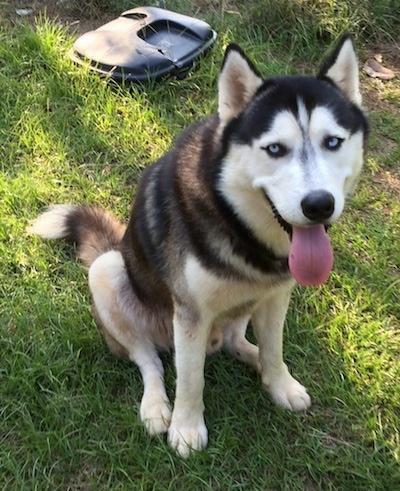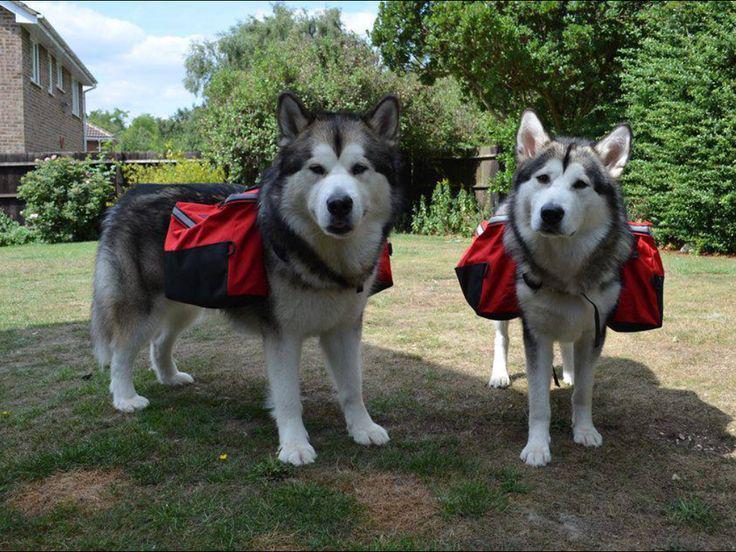The first image is the image on the left, the second image is the image on the right. Assess this claim about the two images: "There are three dogs.". Correct or not? Answer yes or no. Yes. 